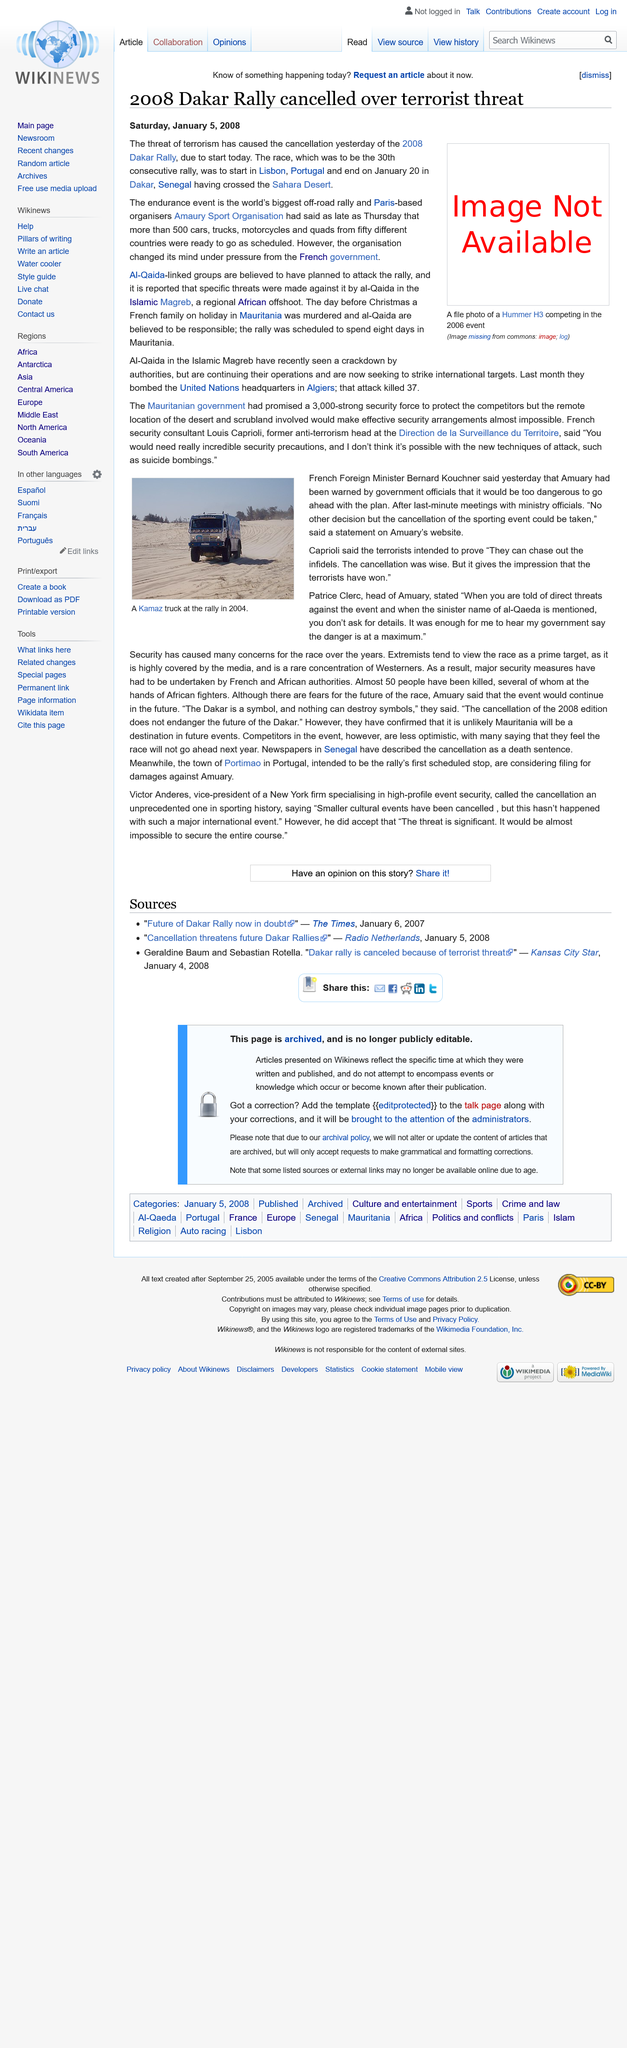Give some essential details in this illustration. The Dakar Rally was scheduled to begin in Lisbon, Portugal in 2008. The image depicts a Kamaz truck, which is a type of vehicle. It is challenging to safeguard competitors in Mauritania due to the remote locations of the desert and scrubland, as well as the emergence of innovative attack strategies, such as suicide bombings. Al-Qaeda issued direct threats against the event. On January 4th, 2008, the 2008 Dakar Rally was cancelled. 